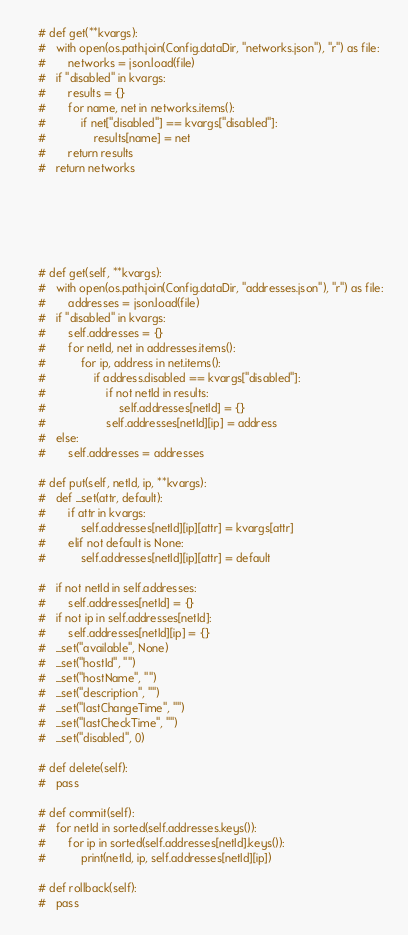<code> <loc_0><loc_0><loc_500><loc_500><_Python_>	# def get(**kvargs):
	# 	with open(os.path.join(Config.dataDir, "networks.json"), "r") as file:
	# 		networks = json.load(file)
	# 	if "disabled" in kvargs:
	# 		results = {}
	# 		for name, net in networks.items():
	# 			if net["disabled"] == kvargs["disabled"]:
	# 				results[name] = net
	# 		return results
	# 	return networks






	# def get(self, **kvargs):
	# 	with open(os.path.join(Config.dataDir, "addresses.json"), "r") as file:
	# 		addresses = json.load(file)
	# 	if "disabled" in kvargs:
	# 		self.addresses = {}
	# 		for netId, net in addresses.items():
	# 			for ip, address in net.items():
	# 				if address.disabled == kvargs["disabled"]:
	# 					if not netId in results:
	# 						self.addresses[netId] = {}
	# 					self.addresses[netId][ip] = address
	# 	else:
	# 		self.addresses = addresses

	# def put(self, netId, ip, **kvargs):
	# 	def _set(attr, default):
	# 		if attr in kvargs:
	# 			self.addresses[netId][ip][attr] = kvargs[attr]
	# 		elif not default is None:
	# 			self.addresses[netId][ip][attr] = default

	# 	if not netId in self.addresses:
	# 		self.addresses[netId] = {}
	# 	if not ip in self.addresses[netId]:
	# 		self.addresses[netId][ip] = {}
	# 	_set("available", None)
	# 	_set("hostId", "")
	# 	_set("hostName", "")
	# 	_set("description", "")
	# 	_set("lastChangeTime", "")
	# 	_set("lastCheckTime", "")
	# 	_set("disabled", 0)

	# def delete(self):
	# 	pass

	# def commit(self):
	# 	for netId in sorted(self.addresses.keys()):
	# 		for ip in sorted(self.addresses[netId].keys()):
	# 			print(netId, ip, self.addresses[netId][ip])

	# def rollback(self):
	# 	pass
</code> 